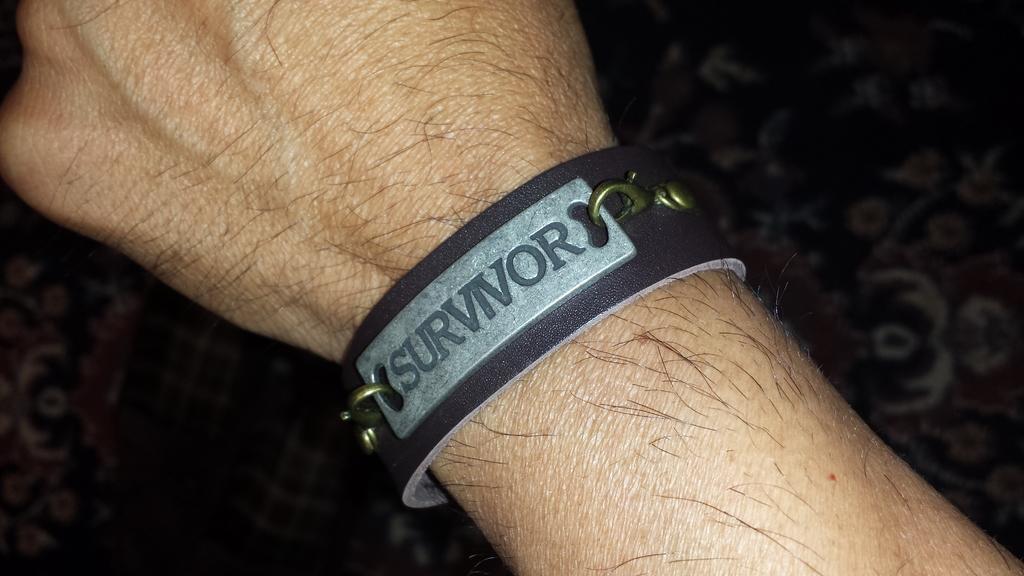Can you describe this image briefly? In this image I can see the band to the person's hand. On the band I can see the name survivor is written. And there is a black and white color background. 